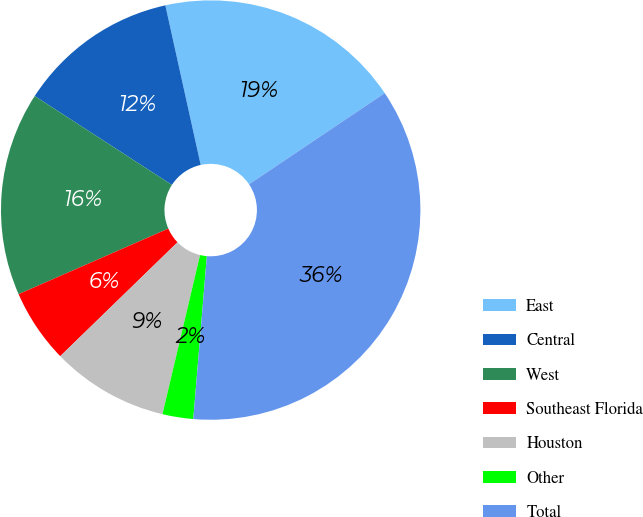<chart> <loc_0><loc_0><loc_500><loc_500><pie_chart><fcel>East<fcel>Central<fcel>West<fcel>Southeast Florida<fcel>Houston<fcel>Other<fcel>Total<nl><fcel>19.05%<fcel>12.38%<fcel>15.72%<fcel>5.7%<fcel>9.04%<fcel>2.37%<fcel>35.74%<nl></chart> 